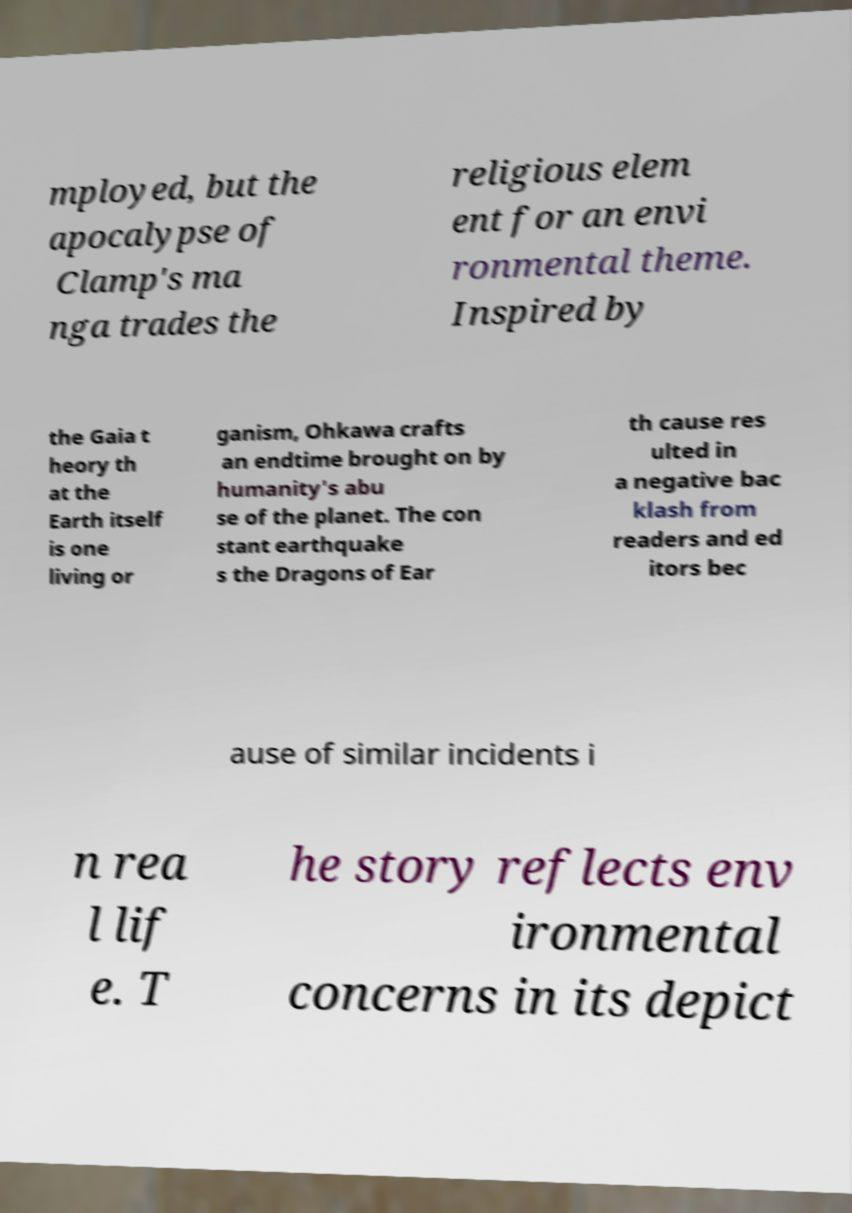For documentation purposes, I need the text within this image transcribed. Could you provide that? mployed, but the apocalypse of Clamp's ma nga trades the religious elem ent for an envi ronmental theme. Inspired by the Gaia t heory th at the Earth itself is one living or ganism, Ohkawa crafts an endtime brought on by humanity's abu se of the planet. The con stant earthquake s the Dragons of Ear th cause res ulted in a negative bac klash from readers and ed itors bec ause of similar incidents i n rea l lif e. T he story reflects env ironmental concerns in its depict 